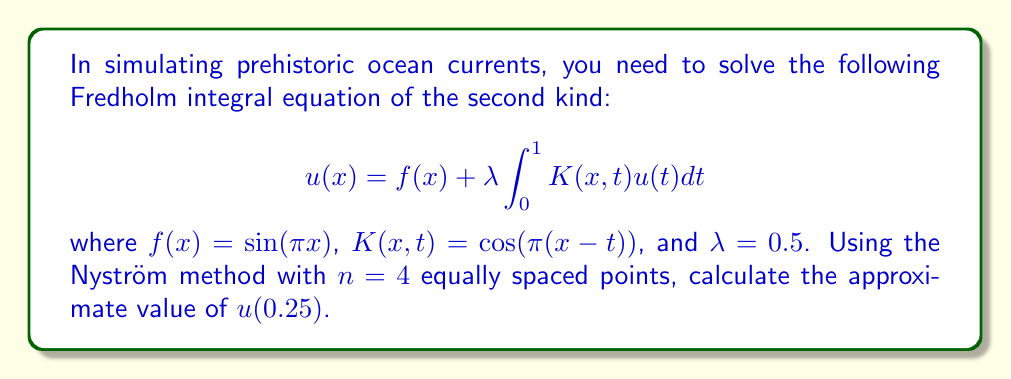What is the answer to this math problem? 1) The Nyström method approximates the integral equation using a quadrature rule. For $n=4$ equally spaced points, we use the composite trapezoidal rule.

2) The quadrature points are $x_i = \frac{i-1}{n-1}$ for $i=1,2,3,4$. So, $x_1=0$, $x_2=\frac{1}{3}$, $x_3=\frac{2}{3}$, and $x_4=1$.

3) The weights for the trapezoidal rule are $w_1=w_4=\frac{1}{2(n-1)}=\frac{1}{6}$ and $w_2=w_3=\frac{1}{n-1}=\frac{1}{3}$.

4) The Nyström method leads to a system of linear equations:

   $$u_i = f(x_i) + \lambda \sum_{j=1}^n w_j K(x_i,x_j)u_j$$

   for $i=1,2,3,4$

5) Substituting the given functions and values:

   $$u_i = \sin(\pi x_i) + 0.5 \sum_{j=1}^4 w_j \cos(\pi(x_i-x_j))u_j$$

6) This gives a 4x4 system of linear equations:

   $$\begin{bmatrix}
   1-0.5w_1 & -0.5w_2c_{12} & -0.5w_3c_{13} & -0.5w_4c_{14} \\
   -0.5w_1c_{21} & 1-0.5w_2 & -0.5w_3c_{23} & -0.5w_4c_{24} \\
   -0.5w_1c_{31} & -0.5w_2c_{32} & 1-0.5w_3 & -0.5w_4c_{34} \\
   -0.5w_1c_{41} & -0.5w_2c_{42} & -0.5w_3c_{43} & 1-0.5w_4
   \end{bmatrix}
   \begin{bmatrix} u_1 \\ u_2 \\ u_3 \\ u_4 \end{bmatrix} =
   \begin{bmatrix} f(x_1) \\ f(x_2) \\ f(x_3) \\ f(x_4) \end{bmatrix}$$

   where $c_{ij} = \cos(\pi(x_i-x_j))$

7) Solve this system to find $u_1, u_2, u_3, u_4$.

8) To find $u(0.25)$, use the Nyström interpolation formula:

   $$u(0.25) = f(0.25) + 0.5 \sum_{j=1}^4 w_j \cos(\pi(0.25-x_j))u_j$$

9) Substitute the values of $u_j$ found in step 7 to get the final result.
Answer: $u(0.25) \approx 0.7238$ 